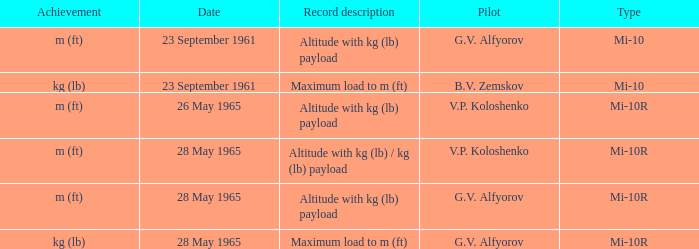Record description of altitude with kg (lb) payload, and a Pilot of g.v. alfyorov had what type? Mi-10, Mi-10R. 